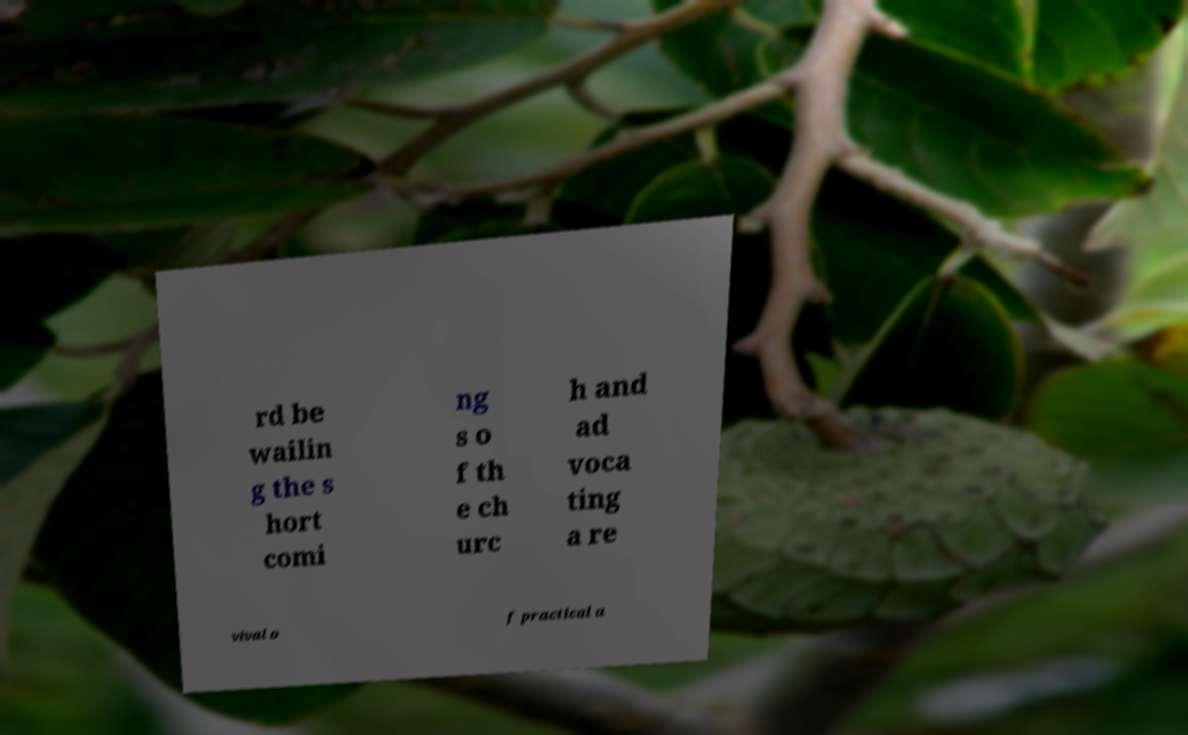There's text embedded in this image that I need extracted. Can you transcribe it verbatim? rd be wailin g the s hort comi ng s o f th e ch urc h and ad voca ting a re vival o f practical a 